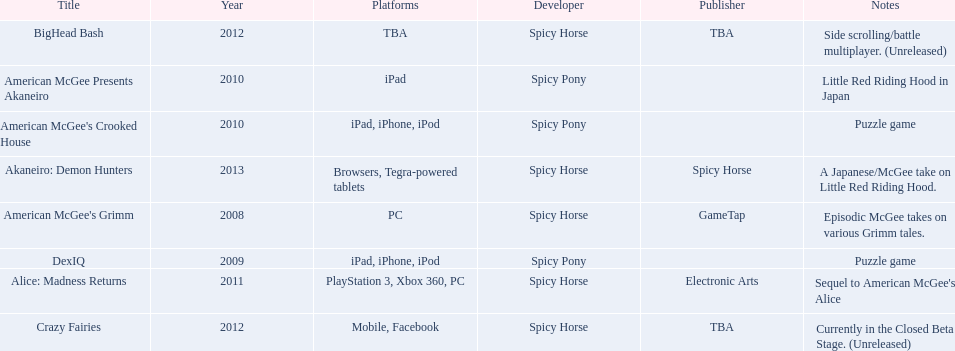What is the first title on this chart? American McGee's Grimm. 